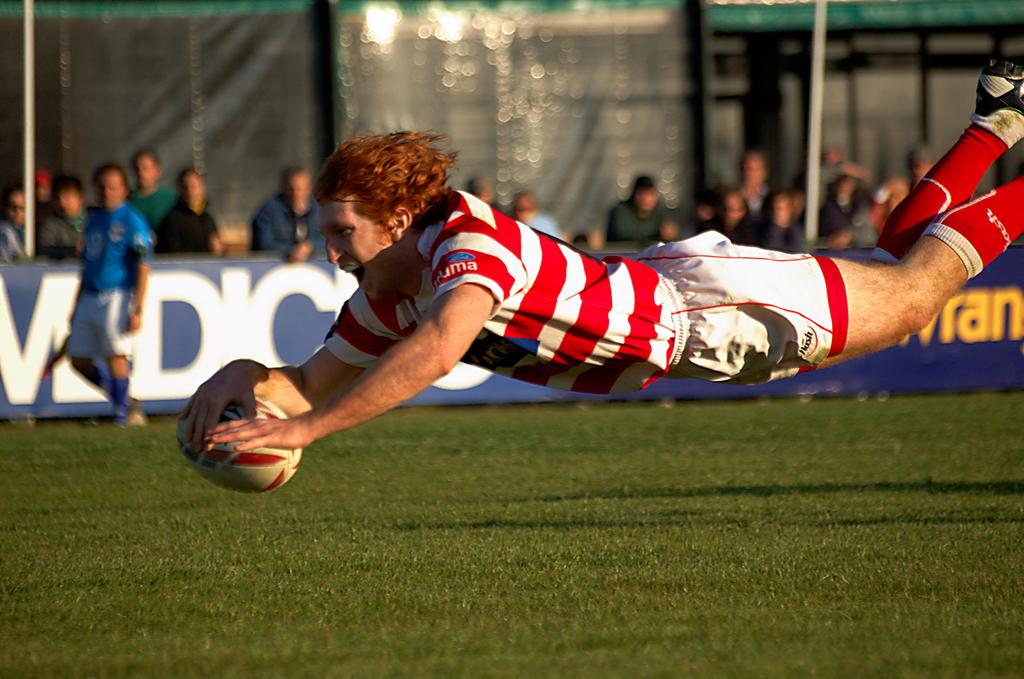What is the person in the image holding? The person in the image is holding a ball. What is the surface beneath the person holding the ball? The person is standing on the ground. What are the people behind the person holding the ball doing? The people are watching the person holding the ball. What type of tomatoes can be seen growing on the person holding the ball? There are no tomatoes present in the image, and the person holding the ball is not a plant. What type of iron is visible in the image? There is no iron present in the image. 